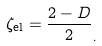<formula> <loc_0><loc_0><loc_500><loc_500>\zeta _ { \text {el} } = \frac { 2 - D } 2 _ { . }</formula> 